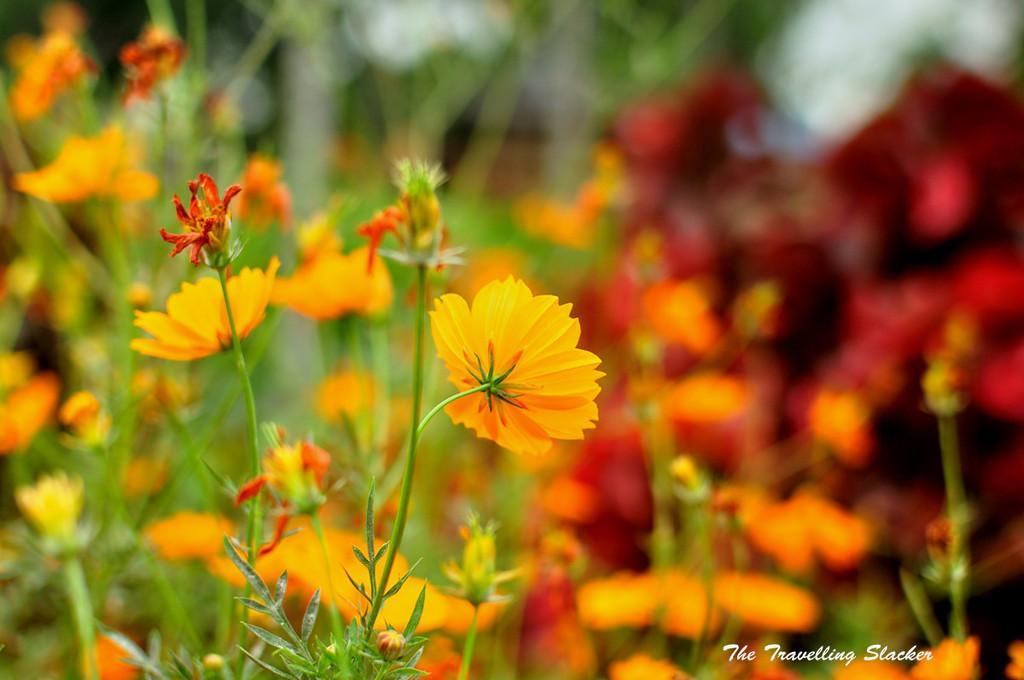In one or two sentences, can you explain what this image depicts? It is an edited image there are beautiful flower plants and among them only the first plant is highlighted, there is some text on the bottom right corner. 